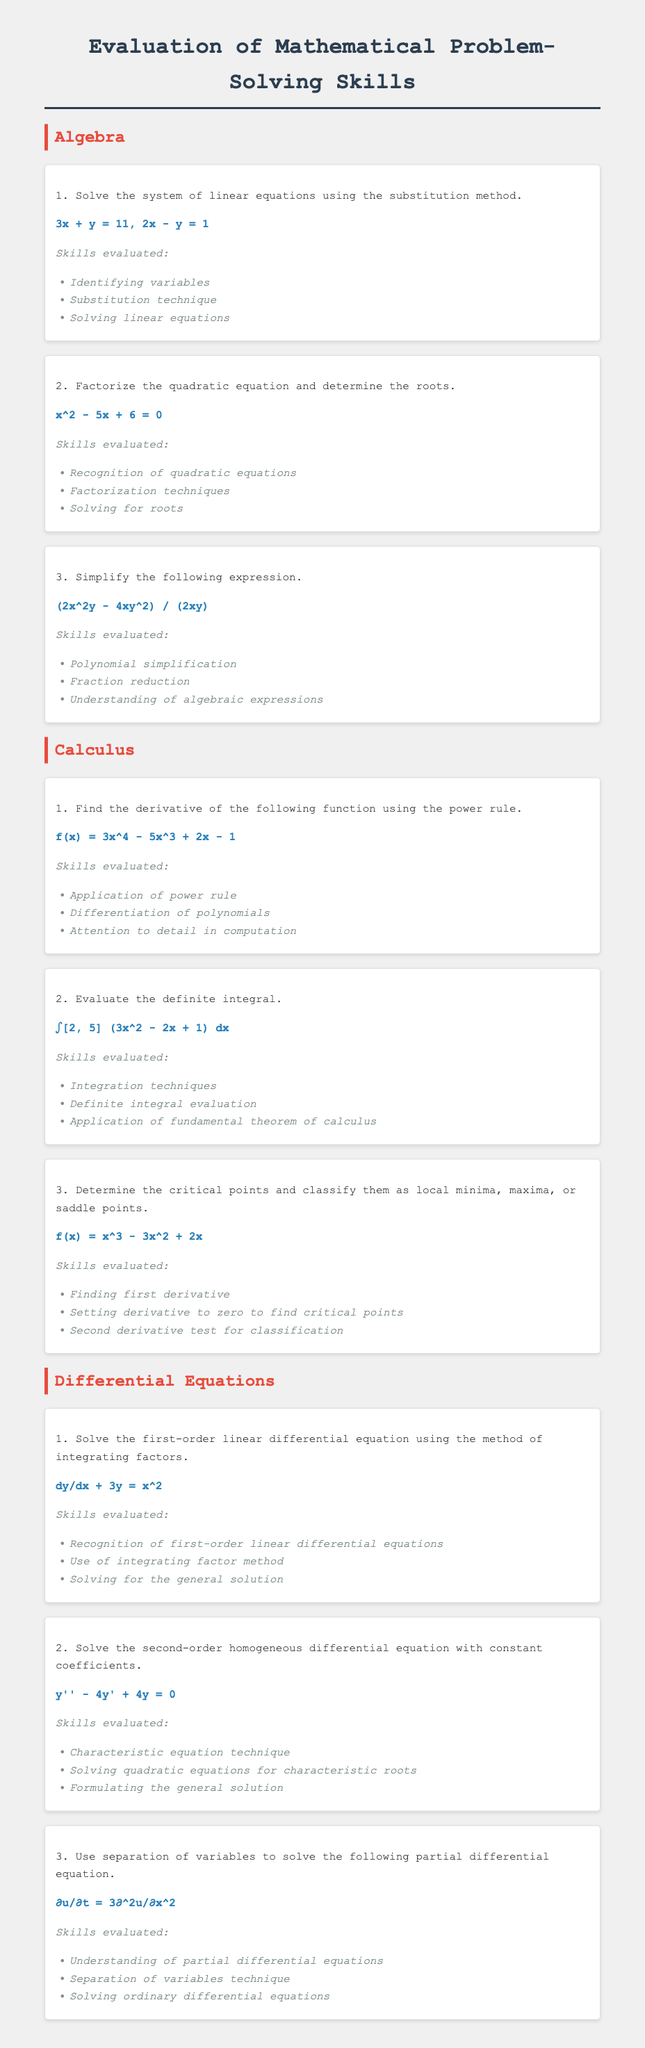what is the first question listed under Algebra? The first question under Algebra involves solving a system of linear equations using the substitution method.
Answer: Solve the system of linear equations using the substitution method how many questions are there in the Calculus section? The Calculus section contains three questions, all asking about different calculus concepts.
Answer: 3 what is the problem statement for the second Algebra question? The second question statement in Algebra asks to factorize a quadratic equation and determine its roots.
Answer: x^2 - 5x + 6 = 0 what method is used to solve the first-order linear differential equation in the Differential Equations section? The document specifies using the method of integrating factors to solve the first-order linear differential equation.
Answer: integrating factors which technique is used for the second question in the Differential Equations section? The second question in the Differential Equations section uses the characteristic equation technique to solve a specific type of differential equation.
Answer: Characteristic equation technique list two skills evaluated in the first Calculus question. The skills evaluated involve the application of the power rule and differentiation of polynomials as indicated in the skills section of the question.
Answer: Application of power rule, Differentiation of polynomials 